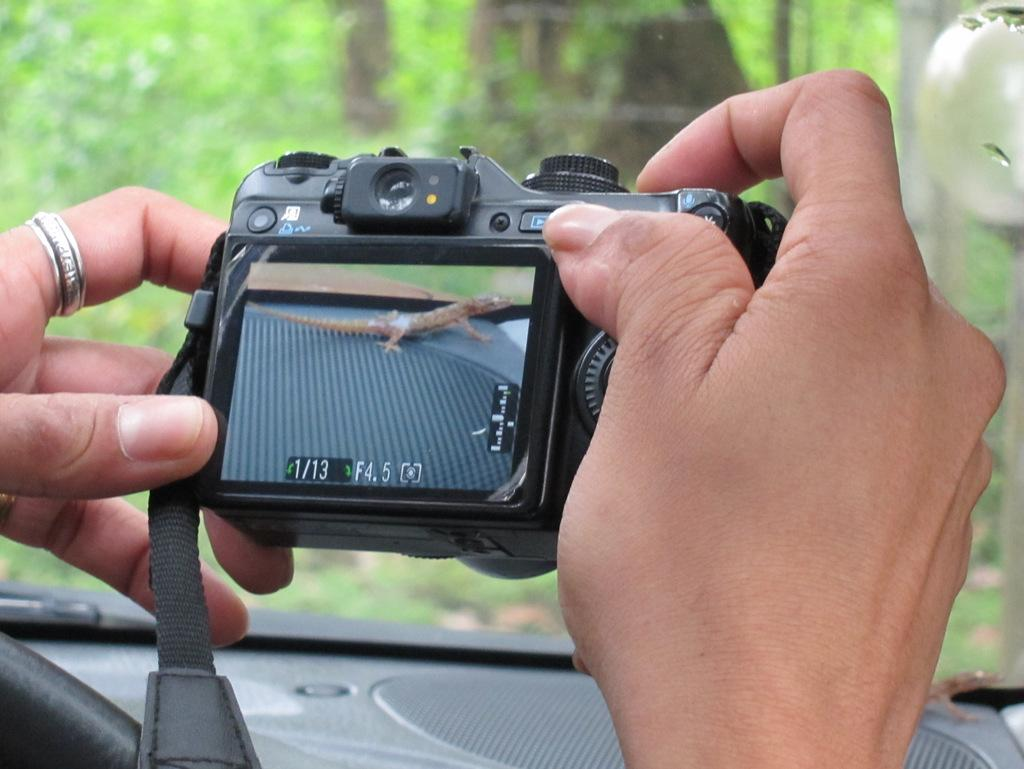<image>
Create a compact narrative representing the image presented. An unknown brand of digital camera with 4.5 marked as F or possibly shutter speed in a pair of hands 